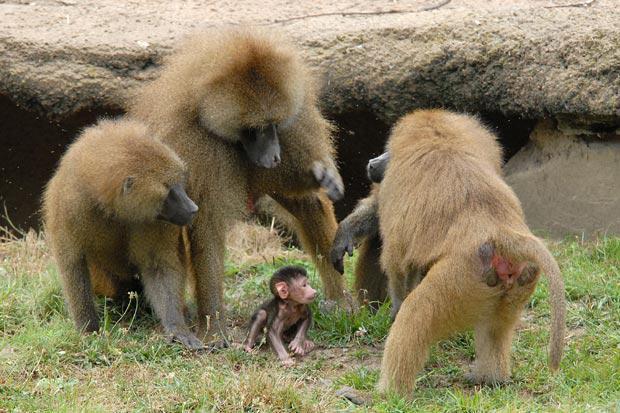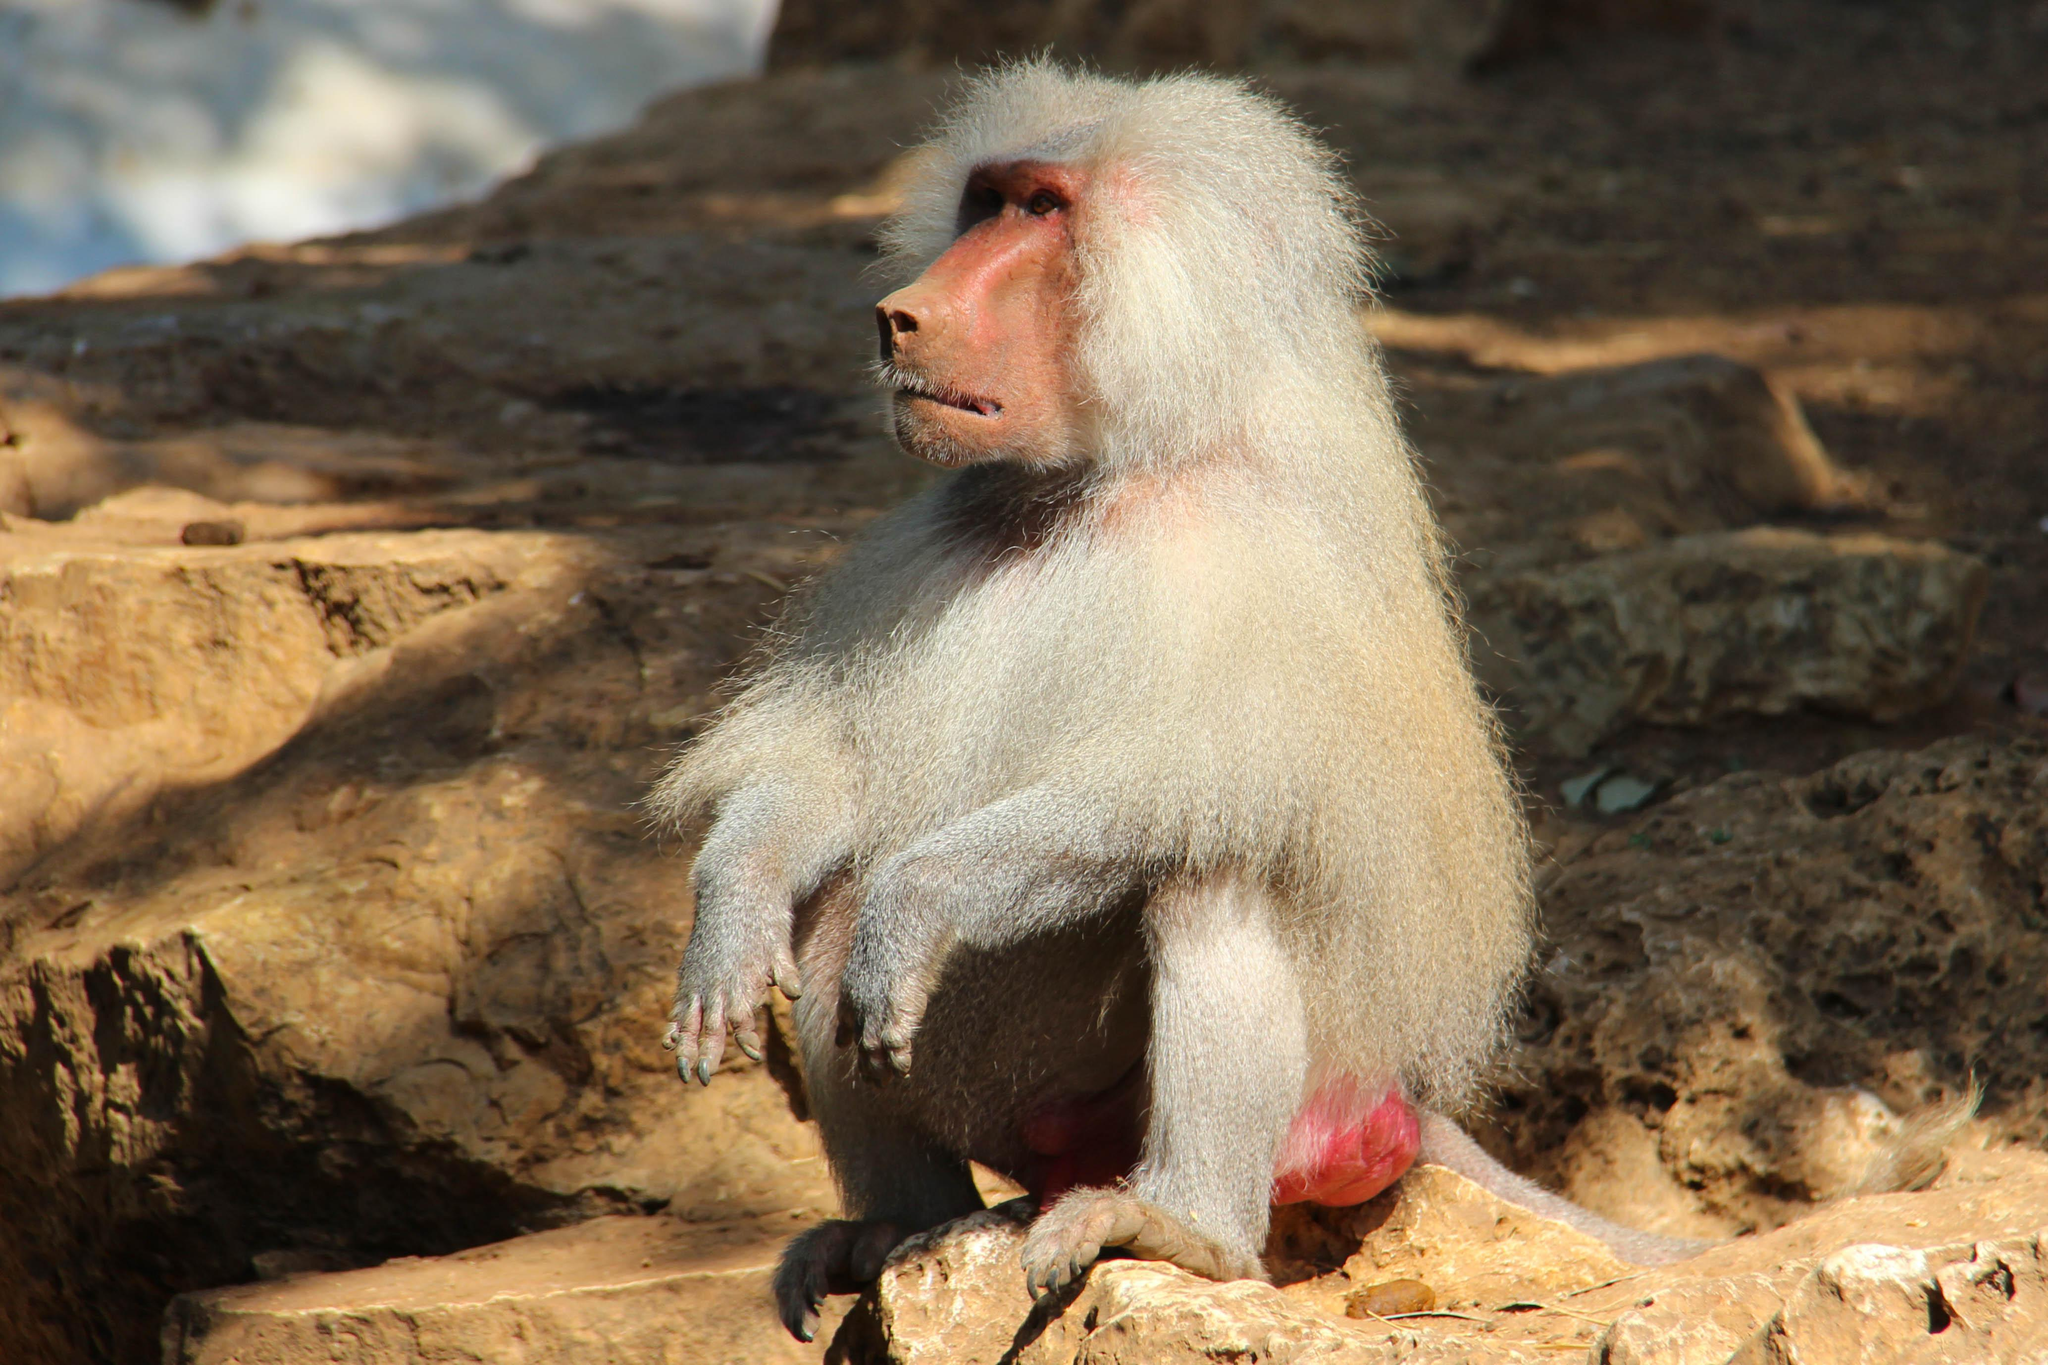The first image is the image on the left, the second image is the image on the right. Considering the images on both sides, is "An image shows only a solitary monkey sitting on a rock." valid? Answer yes or no. Yes. 